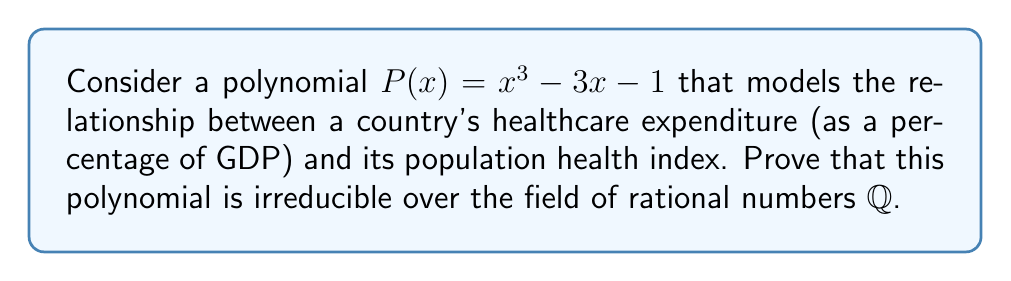Teach me how to tackle this problem. To prove that the polynomial $P(x) = x^3 - 3x - 1$ is irreducible over $\mathbb{Q}$, we can use Eisenstein's criterion. Let's proceed step-by-step:

1) First, recall Eisenstein's criterion: If there exists a prime $p$ such that:
   a) $p$ divides all coefficients except the leading coefficient,
   b) $p^2$ does not divide the constant term,
   c) $p$ does not divide the leading coefficient,
   then the polynomial is irreducible over $\mathbb{Q}$.

2) In our case, $P(x) = x^3 - 3x - 1$. Let's try $p = 3$:

3) Check the conditions:
   a) 3 divides the coefficient of $x$ ($-3$)
   b) $3^2 = 9$ does not divide the constant term $-1$
   c) 3 does not divide the leading coefficient 1

4) All conditions of Eisenstein's criterion are satisfied for $p = 3$.

5) Therefore, by Eisenstein's criterion, $P(x) = x^3 - 3x - 1$ is irreducible over $\mathbb{Q}$.

This irreducibility suggests that the relationship between healthcare expenditure and population health index, as modeled by this polynomial, cannot be simplified into lower-degree factors over the rational numbers, indicating a complex, non-linear relationship between these variables in global health contexts.
Answer: $P(x) = x^3 - 3x - 1$ is irreducible over $\mathbb{Q}$ by Eisenstein's criterion with $p = 3$. 